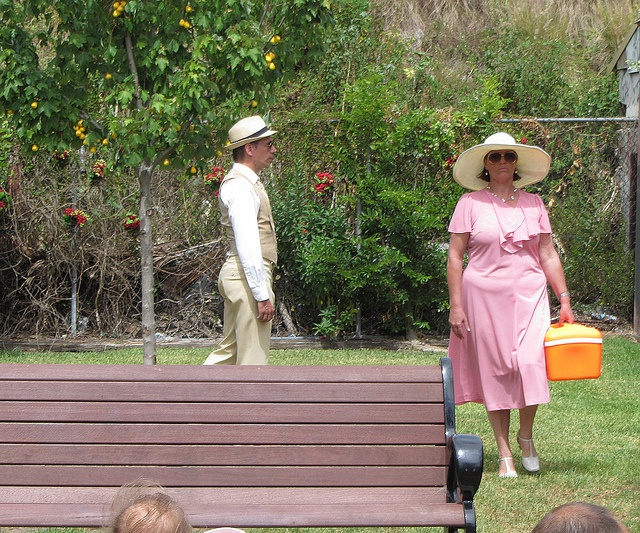Describe the objects in this image and their specific colors. I can see bench in gray, darkgray, pink, and black tones, people in gray, pink, lightpink, and brown tones, people in gray, white, and darkgray tones, handbag in gray, orange, ivory, red, and khaki tones, and people in teal, gray, tan, and darkgray tones in this image. 